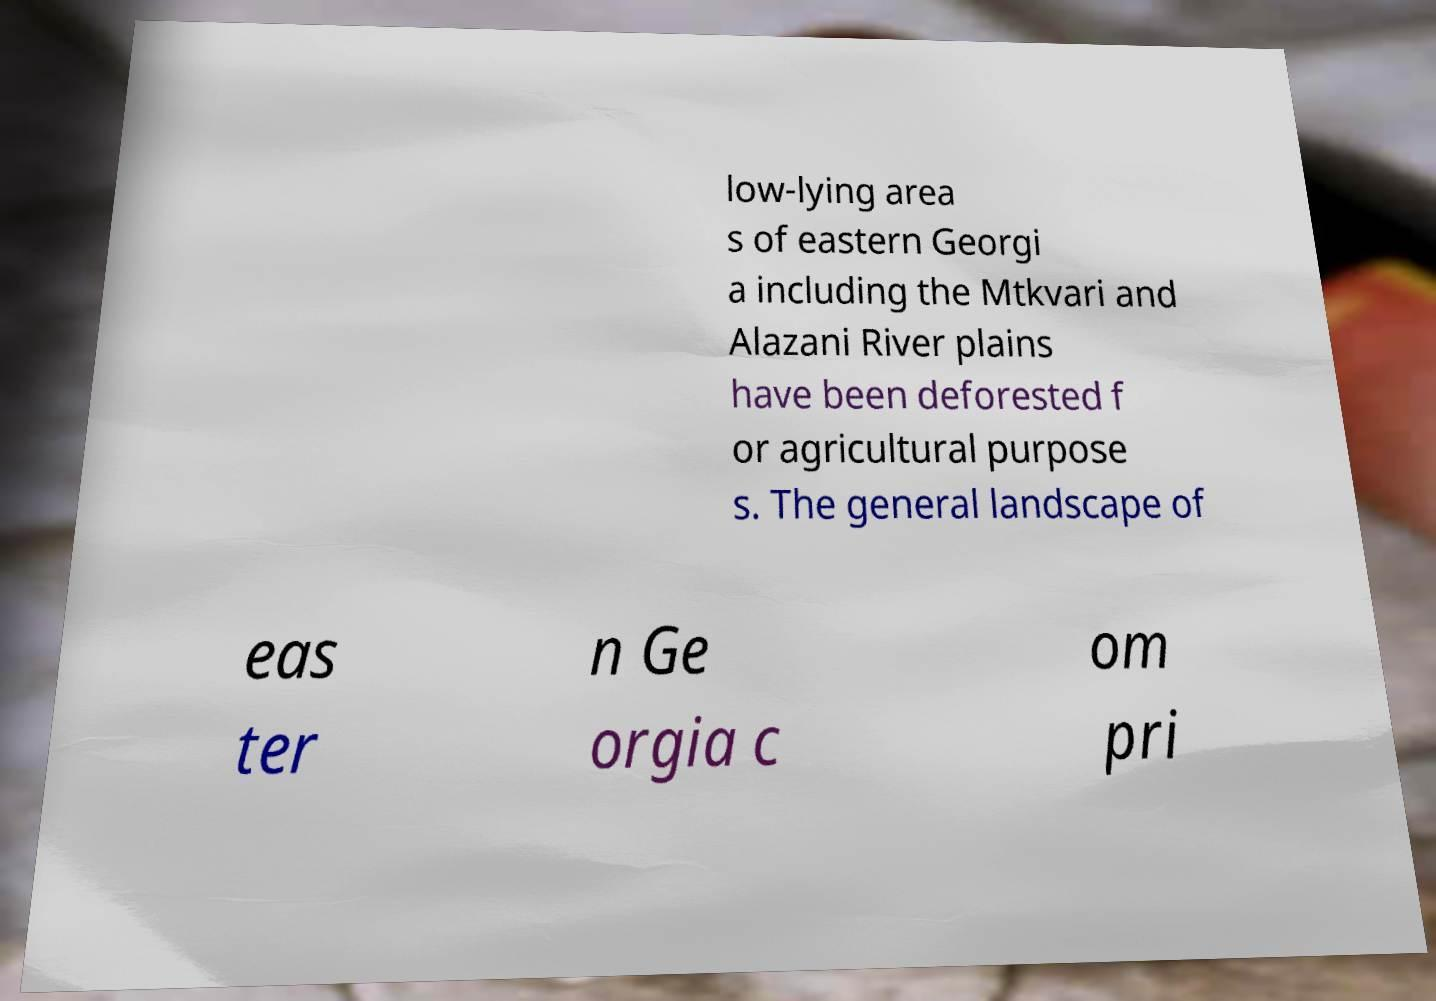There's text embedded in this image that I need extracted. Can you transcribe it verbatim? low-lying area s of eastern Georgi a including the Mtkvari and Alazani River plains have been deforested f or agricultural purpose s. The general landscape of eas ter n Ge orgia c om pri 